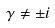<formula> <loc_0><loc_0><loc_500><loc_500>\gamma \ne \pm i</formula> 